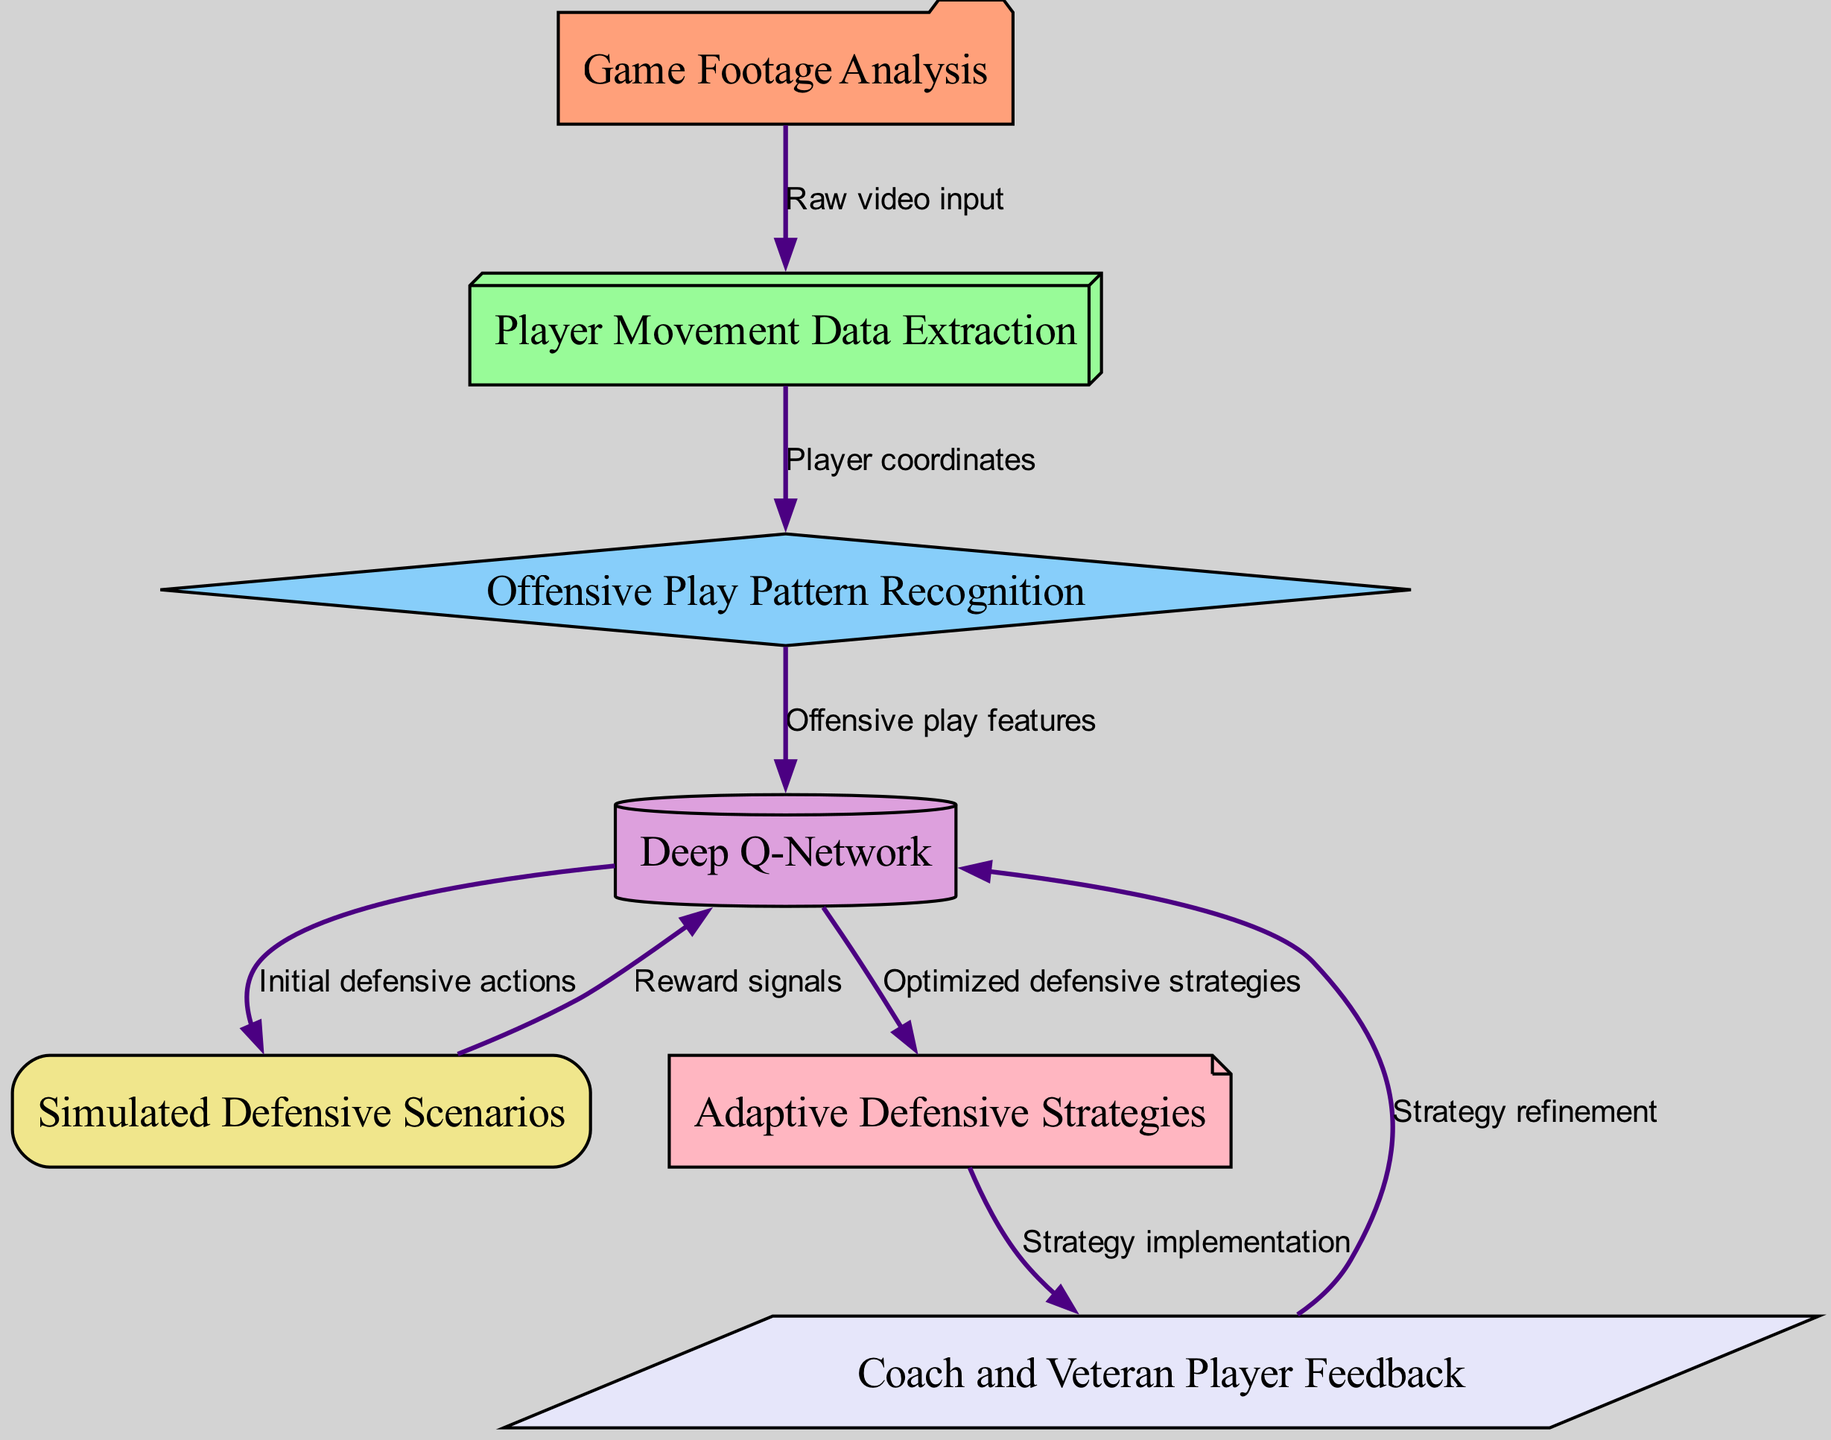What is the first step in the diagram? The diagram begins with "Game Footage Analysis," which is the input stage. This initial step collects raw video input of games for further processing.
Answer: Game Footage Analysis How many nodes are present in the diagram? By counting all the nodes listed in the data, we identify seven nodes: Game Footage Analysis, Player Movement Data Extraction, Offensive Play Pattern Recognition, Deep Q-Network, Simulated Defensive Scenarios, Adaptive Defensive Strategies, and Coach and Veteran Player Feedback.
Answer: 7 What connects "Deep Q-Network" to "Simulated Defensive Scenarios"? The connection is established via the edge labeled "Initial defensive actions," indicating the output of the model is feeding into the training process.
Answer: Initial defensive actions Which node receives feedback after the strategy implementation? The node labeled "Deep Q-Network" receives feedback from the "Coach and Veteran Player Feedback" node after the adaptive defensive strategies are implemented in the game context.
Answer: Deep Q-Network How does the "Player Movement Data Extraction" node relate to the "Offensive Play Pattern Recognition" node? The transition between these two nodes is facilitated through player coordinates, which are extracted during preprocessing to identify play patterns in the following step.
Answer: Player coordinates What is the last step in the diagram? The final node in the diagram is "Adaptive Defensive Strategies," which represents the output of the entire system after processing and training.
Answer: Adaptive Defensive Strategies What type of learning is represented by the "Deep Q-Network"? The learning type illustrated here is reinforcement learning, where a model optimizes actions based on rewards received during training scenarios.
Answer: Reinforcement learning What is the feedback used for in the diagram? The feedback is utilized for "Strategy refinement," allowing the model to improve its adaptive defensive strategies by incorporating insights from experienced players.
Answer: Strategy refinement 